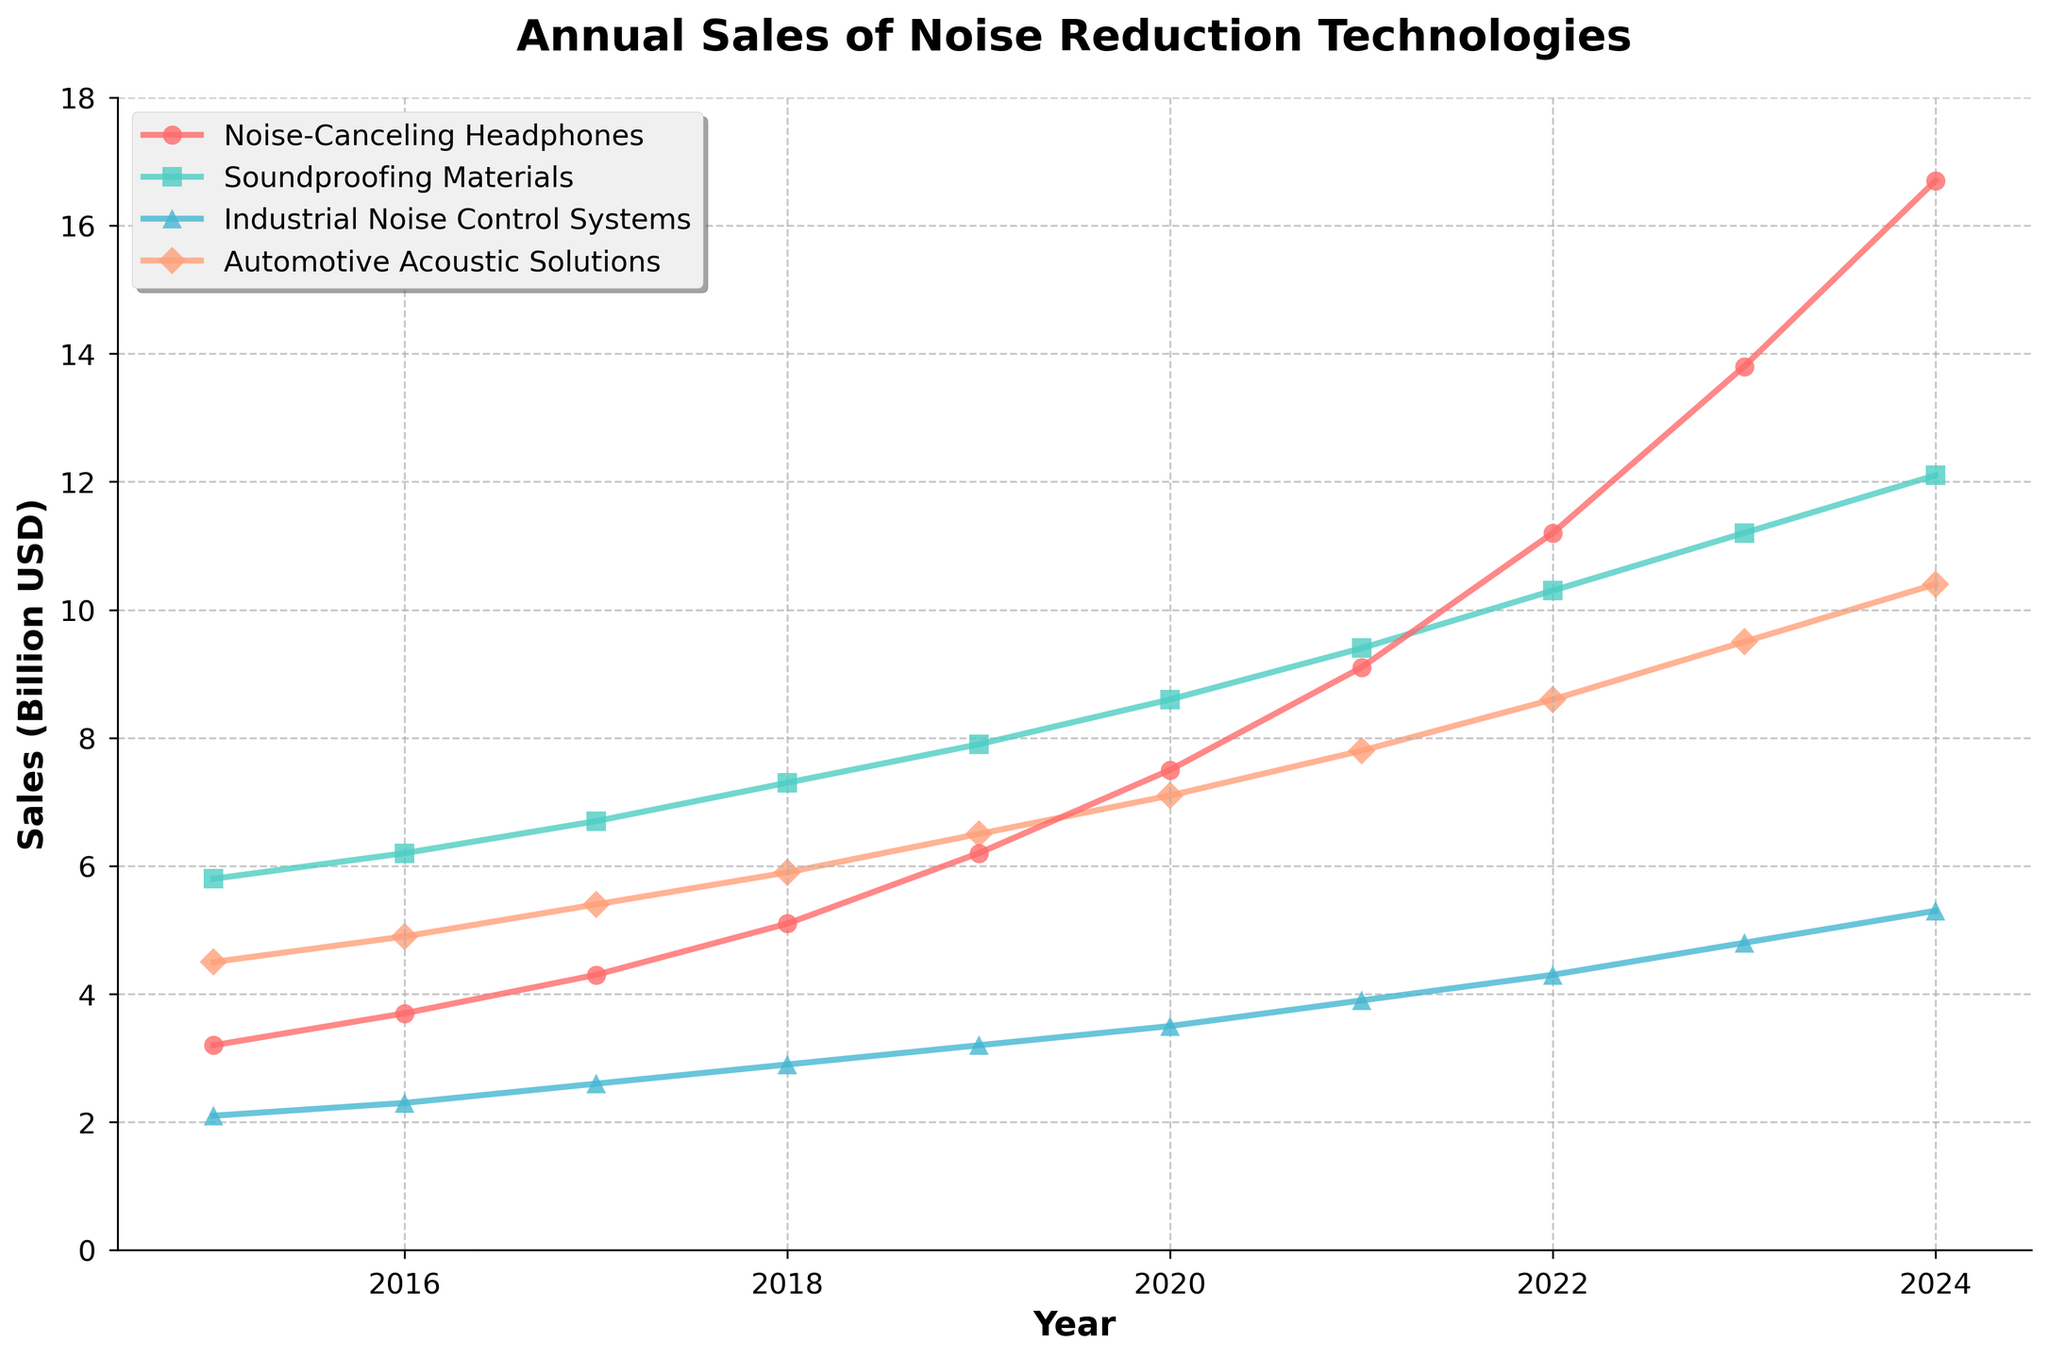Which category had the highest sales in 2024? Look at the tallest line marker in the 2024 column. The "Noise-Canceling Headphones" line at 16.7 billion USD is the highest.
Answer: Noise-Canceling Headphones What is the difference in sales between Soundproofing Materials and Industrial Noise Control Systems in 2020? In 2020, Soundproofing Materials had 8.6 billion USD and Industrial Noise Control Systems had 3.5 billion USD. The difference is 8.6 - 3.5 = 5.1 billion USD.
Answer: 5.1 billion USD How did the sales of Automotive Acoustic Solutions change from 2015 to 2024? In 2015, Automotive Acoustic Solutions sales were 4.5 billion USD. In 2024, they were 10.4 billion USD. The sales increased by 10.4 - 4.5 = 5.9 billion USD.
Answer: Increased by 5.9 billion USD Which year did Noise-Canceling Headphones surpass 10 billion USD in sales? Follow the line for Noise-Canceling Headphones until it goes above 10 billion USD. It surpasses 10 billion USD in 2022 with 11.2 billion USD.
Answer: 2022 In which year did Soundproofing Materials achieve its highest growth rate, and what was the growth rate? Calculate the year-over-year growth rates for Soundproofing Materials and find the maximum. From 2022 to 2023, 11.2 - 10.3 = 0.9, growth is (0.9/10.3) * 100 = 8.74%. It's the highest growth rate among the years.
Answer: 2023, 8.74% Compare the sales of Industrial Noise Control Systems and Automotive Acoustic Solutions in 2019. Which was higher and by how much? In 2019, Industrial Noise Control Systems had 3.2 billion USD and Automotive Acoustic Solutions had 6.5 billion USD. The difference is 6.5 - 3.2 = 3.3 billion USD.
Answer: Automotive Acoustic Solutions, by 3.3 billion USD What was the average annual sales for Soundproofing Materials from 2015 to 2024? Sum up the sales values from 2015 to 2024 and divide by the number of years. (5.8 + 6.2 + 6.7 + 7.3 + 7.9 + 8.6 + 9.4 + 10.3 + 11.2 + 12.1) / 10 = 85.5 / 10 = 8.55 billion USD.
Answer: 8.55 billion USD In which year did Industrial Noise Control Systems see the largest annual increase in sales, and what was the increase? Calculate the year-over-year increases and find the largest. From 2022 to 2023, 4.8 - 4.3 = 0.5 billion USD, the largest increase.
Answer: 2023, 0.5 billion USD By how much did the sales of Noise-Canceling Headphones exceed the sales of Soundproofing Materials in 2024? In 2024, Noise-Canceling Headphones had 16.7 billion USD and Soundproofing Materials had 12.1 billion USD. The difference is 16.7 - 12.1 = 4.6 billion USD.
Answer: 4.6 billion USD 